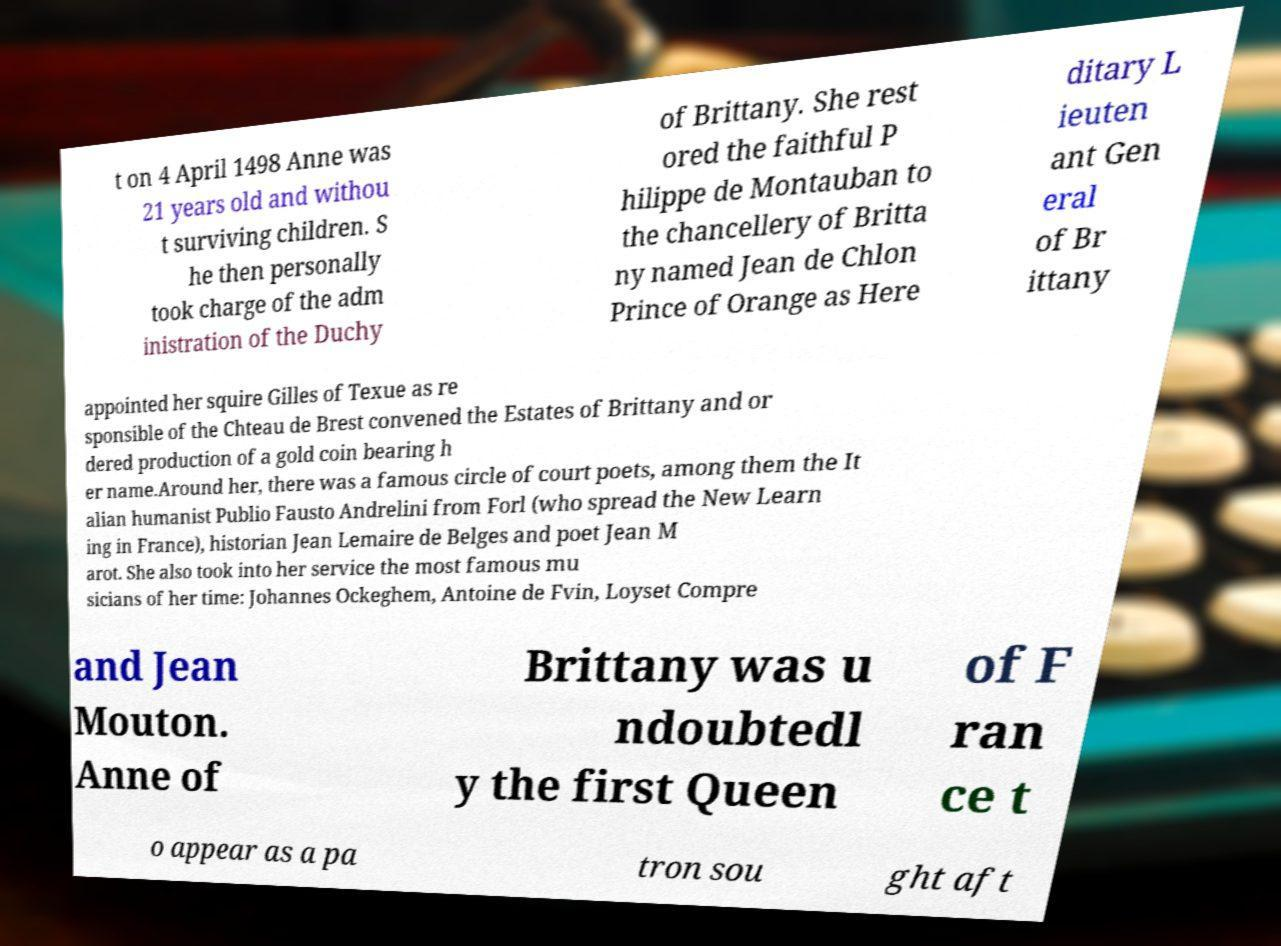Please identify and transcribe the text found in this image. t on 4 April 1498 Anne was 21 years old and withou t surviving children. S he then personally took charge of the adm inistration of the Duchy of Brittany. She rest ored the faithful P hilippe de Montauban to the chancellery of Britta ny named Jean de Chlon Prince of Orange as Here ditary L ieuten ant Gen eral of Br ittany appointed her squire Gilles of Texue as re sponsible of the Chteau de Brest convened the Estates of Brittany and or dered production of a gold coin bearing h er name.Around her, there was a famous circle of court poets, among them the It alian humanist Publio Fausto Andrelini from Forl (who spread the New Learn ing in France), historian Jean Lemaire de Belges and poet Jean M arot. She also took into her service the most famous mu sicians of her time: Johannes Ockeghem, Antoine de Fvin, Loyset Compre and Jean Mouton. Anne of Brittany was u ndoubtedl y the first Queen of F ran ce t o appear as a pa tron sou ght aft 